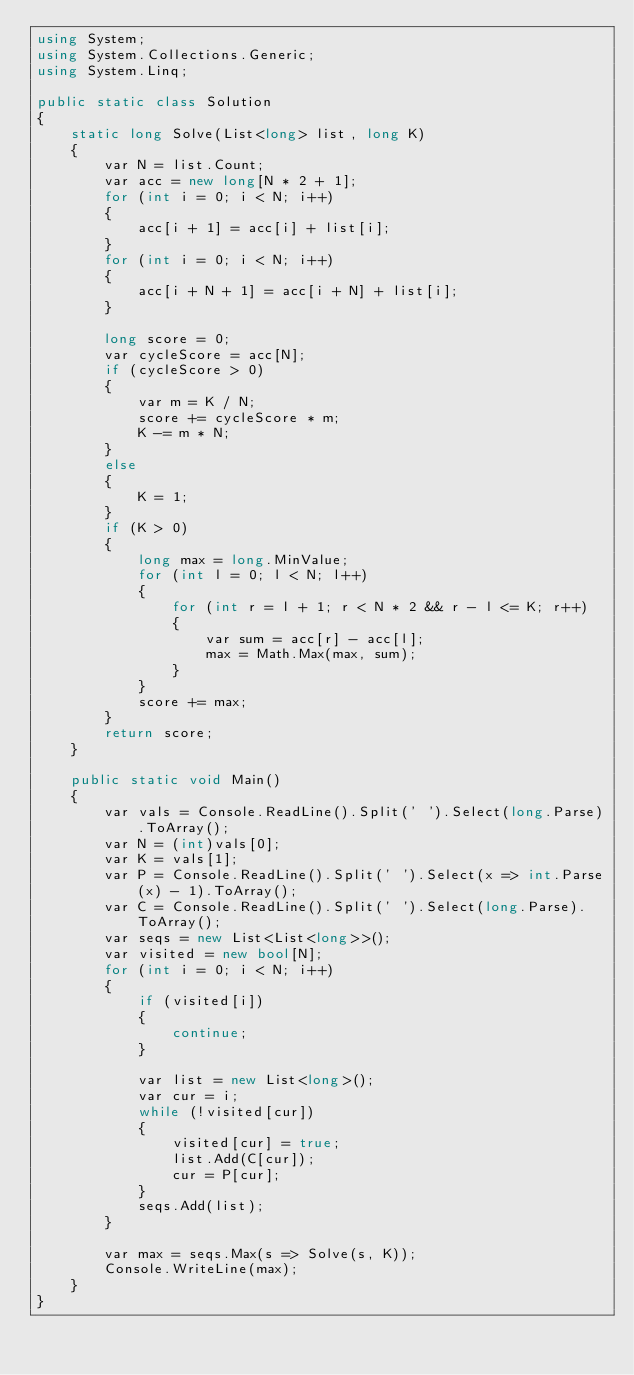Convert code to text. <code><loc_0><loc_0><loc_500><loc_500><_C#_>using System;
using System.Collections.Generic;
using System.Linq;

public static class Solution
{
    static long Solve(List<long> list, long K)
    {
        var N = list.Count;
        var acc = new long[N * 2 + 1];
        for (int i = 0; i < N; i++)
        {
            acc[i + 1] = acc[i] + list[i];
        }
        for (int i = 0; i < N; i++)
        {
            acc[i + N + 1] = acc[i + N] + list[i];
        }

        long score = 0;
        var cycleScore = acc[N];
        if (cycleScore > 0)
        {
            var m = K / N;
            score += cycleScore * m;
            K -= m * N;
        }
        else
        {
            K = 1;
        }
        if (K > 0)
        {
            long max = long.MinValue;
            for (int l = 0; l < N; l++)
            {
                for (int r = l + 1; r < N * 2 && r - l <= K; r++)
                {
                    var sum = acc[r] - acc[l];
                    max = Math.Max(max, sum);
                }
            }
            score += max;
        }
        return score;
    }

    public static void Main()
    {
        var vals = Console.ReadLine().Split(' ').Select(long.Parse).ToArray();
        var N = (int)vals[0];
        var K = vals[1];
        var P = Console.ReadLine().Split(' ').Select(x => int.Parse(x) - 1).ToArray();
        var C = Console.ReadLine().Split(' ').Select(long.Parse).ToArray();
        var seqs = new List<List<long>>();
        var visited = new bool[N];
        for (int i = 0; i < N; i++)
        {
            if (visited[i])
            {
                continue;
            }

            var list = new List<long>();
            var cur = i;
            while (!visited[cur])
            {
                visited[cur] = true;
                list.Add(C[cur]);
                cur = P[cur];
            }
            seqs.Add(list);
        }

        var max = seqs.Max(s => Solve(s, K));
        Console.WriteLine(max);
    }
}</code> 